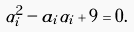Convert formula to latex. <formula><loc_0><loc_0><loc_500><loc_500>\alpha _ { i } ^ { 2 } - a _ { i } \alpha _ { i } + 9 = 0 .</formula> 